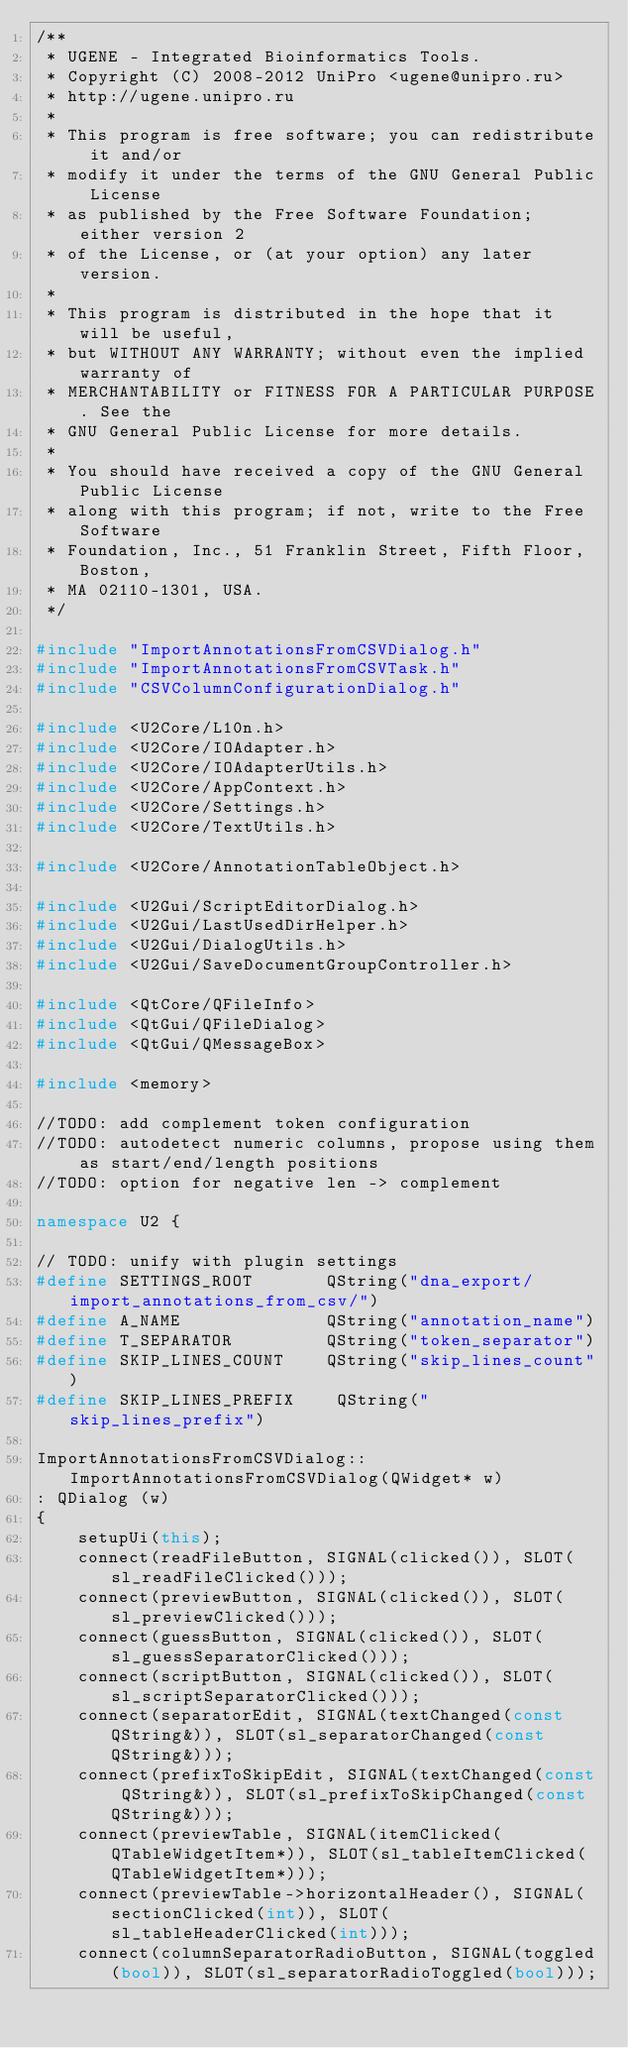Convert code to text. <code><loc_0><loc_0><loc_500><loc_500><_C++_>/**
 * UGENE - Integrated Bioinformatics Tools.
 * Copyright (C) 2008-2012 UniPro <ugene@unipro.ru>
 * http://ugene.unipro.ru
 *
 * This program is free software; you can redistribute it and/or
 * modify it under the terms of the GNU General Public License
 * as published by the Free Software Foundation; either version 2
 * of the License, or (at your option) any later version.
 *
 * This program is distributed in the hope that it will be useful,
 * but WITHOUT ANY WARRANTY; without even the implied warranty of
 * MERCHANTABILITY or FITNESS FOR A PARTICULAR PURPOSE. See the
 * GNU General Public License for more details.
 *
 * You should have received a copy of the GNU General Public License
 * along with this program; if not, write to the Free Software
 * Foundation, Inc., 51 Franklin Street, Fifth Floor, Boston,
 * MA 02110-1301, USA.
 */

#include "ImportAnnotationsFromCSVDialog.h"
#include "ImportAnnotationsFromCSVTask.h"
#include "CSVColumnConfigurationDialog.h"

#include <U2Core/L10n.h>
#include <U2Core/IOAdapter.h>
#include <U2Core/IOAdapterUtils.h>
#include <U2Core/AppContext.h>
#include <U2Core/Settings.h>
#include <U2Core/TextUtils.h>

#include <U2Core/AnnotationTableObject.h>

#include <U2Gui/ScriptEditorDialog.h>
#include <U2Gui/LastUsedDirHelper.h>
#include <U2Gui/DialogUtils.h>
#include <U2Gui/SaveDocumentGroupController.h>

#include <QtCore/QFileInfo>
#include <QtGui/QFileDialog>
#include <QtGui/QMessageBox>

#include <memory>

//TODO: add complement token configuration
//TODO: autodetect numeric columns, propose using them as start/end/length positions
//TODO: option for negative len -> complement

namespace U2 {

// TODO: unify with plugin settings
#define SETTINGS_ROOT       QString("dna_export/import_annotations_from_csv/")
#define A_NAME              QString("annotation_name")
#define T_SEPARATOR         QString("token_separator")
#define SKIP_LINES_COUNT    QString("skip_lines_count")
#define SKIP_LINES_PREFIX    QString("skip_lines_prefix")

ImportAnnotationsFromCSVDialog::ImportAnnotationsFromCSVDialog(QWidget* w) 
: QDialog (w)
{
    setupUi(this);
    connect(readFileButton, SIGNAL(clicked()), SLOT(sl_readFileClicked()));
    connect(previewButton, SIGNAL(clicked()), SLOT(sl_previewClicked()));
    connect(guessButton, SIGNAL(clicked()), SLOT(sl_guessSeparatorClicked()));
    connect(scriptButton, SIGNAL(clicked()), SLOT(sl_scriptSeparatorClicked()));
    connect(separatorEdit, SIGNAL(textChanged(const QString&)), SLOT(sl_separatorChanged(const QString&)));
    connect(prefixToSkipEdit, SIGNAL(textChanged(const QString&)), SLOT(sl_prefixToSkipChanged(const QString&)));
    connect(previewTable, SIGNAL(itemClicked(QTableWidgetItem*)), SLOT(sl_tableItemClicked(QTableWidgetItem*)));
    connect(previewTable->horizontalHeader(), SIGNAL(sectionClicked(int)), SLOT(sl_tableHeaderClicked(int)));
    connect(columnSeparatorRadioButton, SIGNAL(toggled(bool)), SLOT(sl_separatorRadioToggled(bool)));</code> 